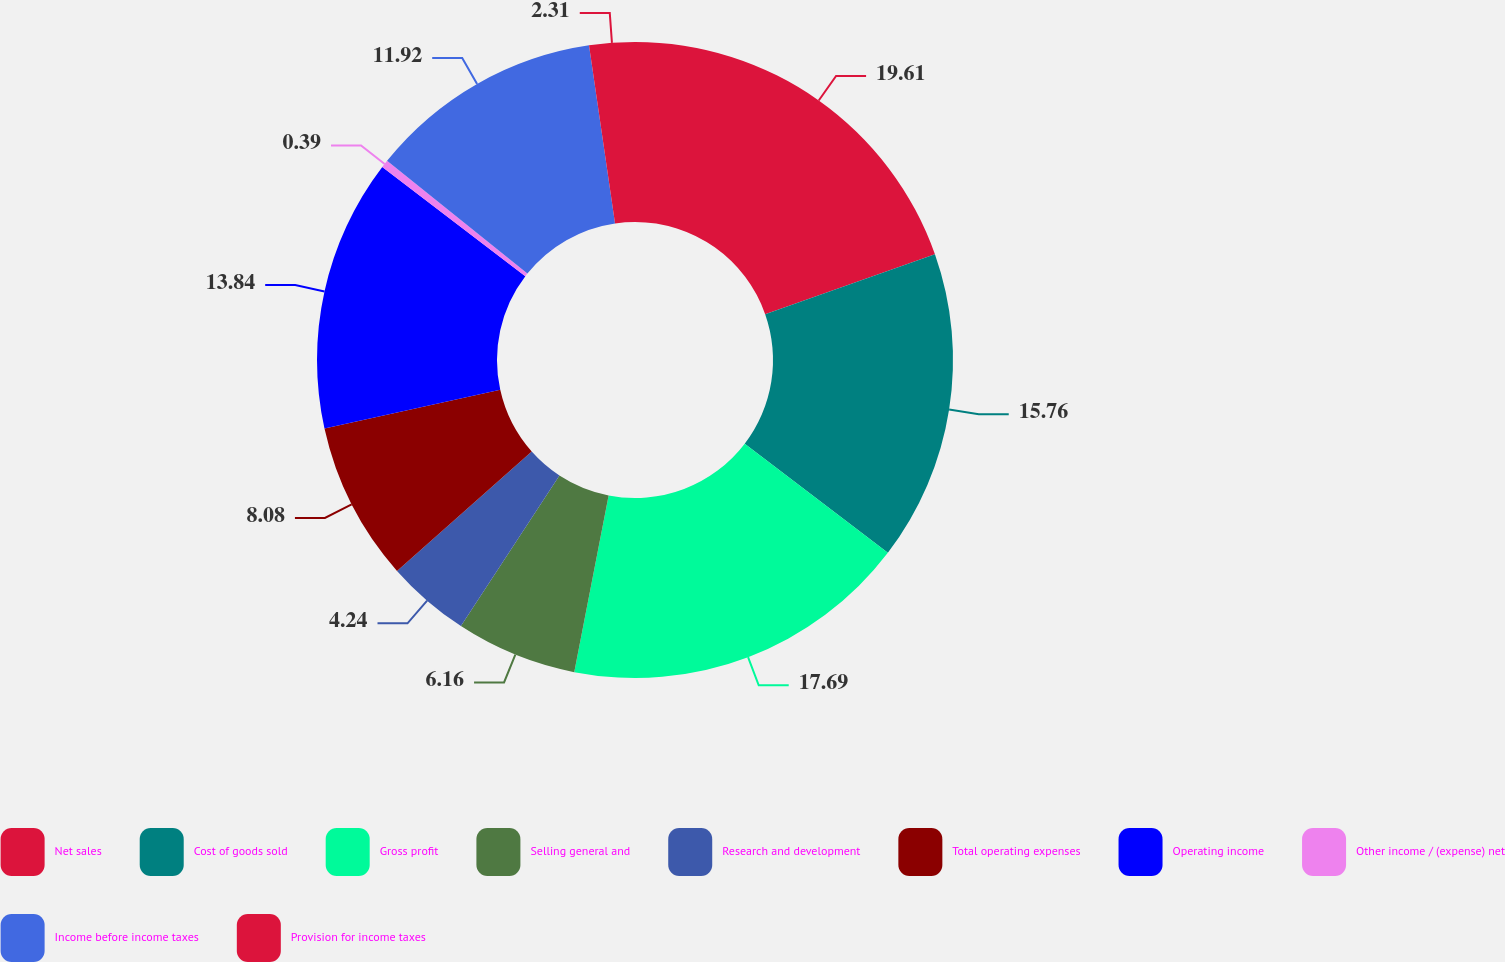<chart> <loc_0><loc_0><loc_500><loc_500><pie_chart><fcel>Net sales<fcel>Cost of goods sold<fcel>Gross profit<fcel>Selling general and<fcel>Research and development<fcel>Total operating expenses<fcel>Operating income<fcel>Other income / (expense) net<fcel>Income before income taxes<fcel>Provision for income taxes<nl><fcel>19.61%<fcel>15.76%<fcel>17.69%<fcel>6.16%<fcel>4.24%<fcel>8.08%<fcel>13.84%<fcel>0.39%<fcel>11.92%<fcel>2.31%<nl></chart> 